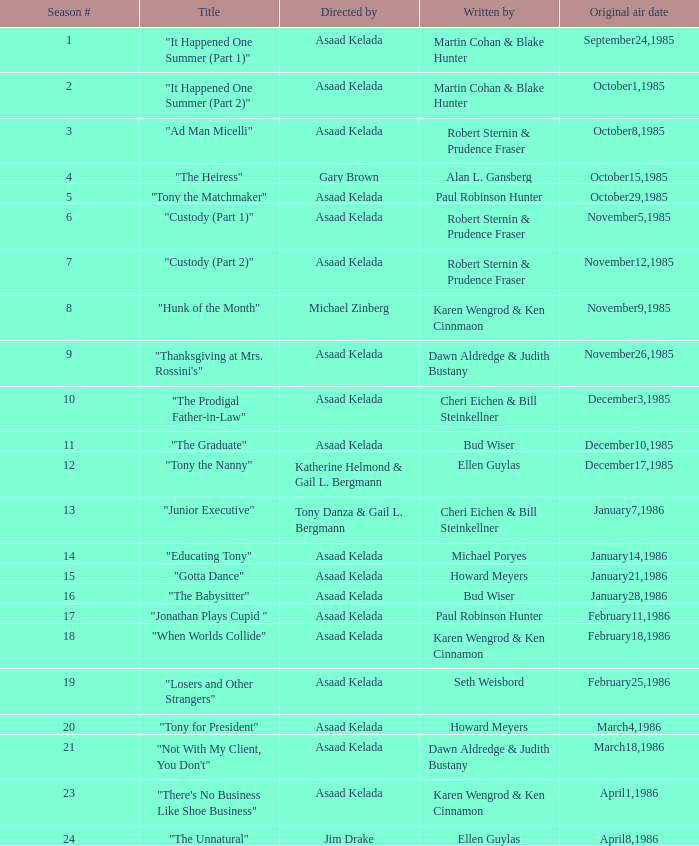What is the season where the episode "when worlds collide" was shown? 18.0. 